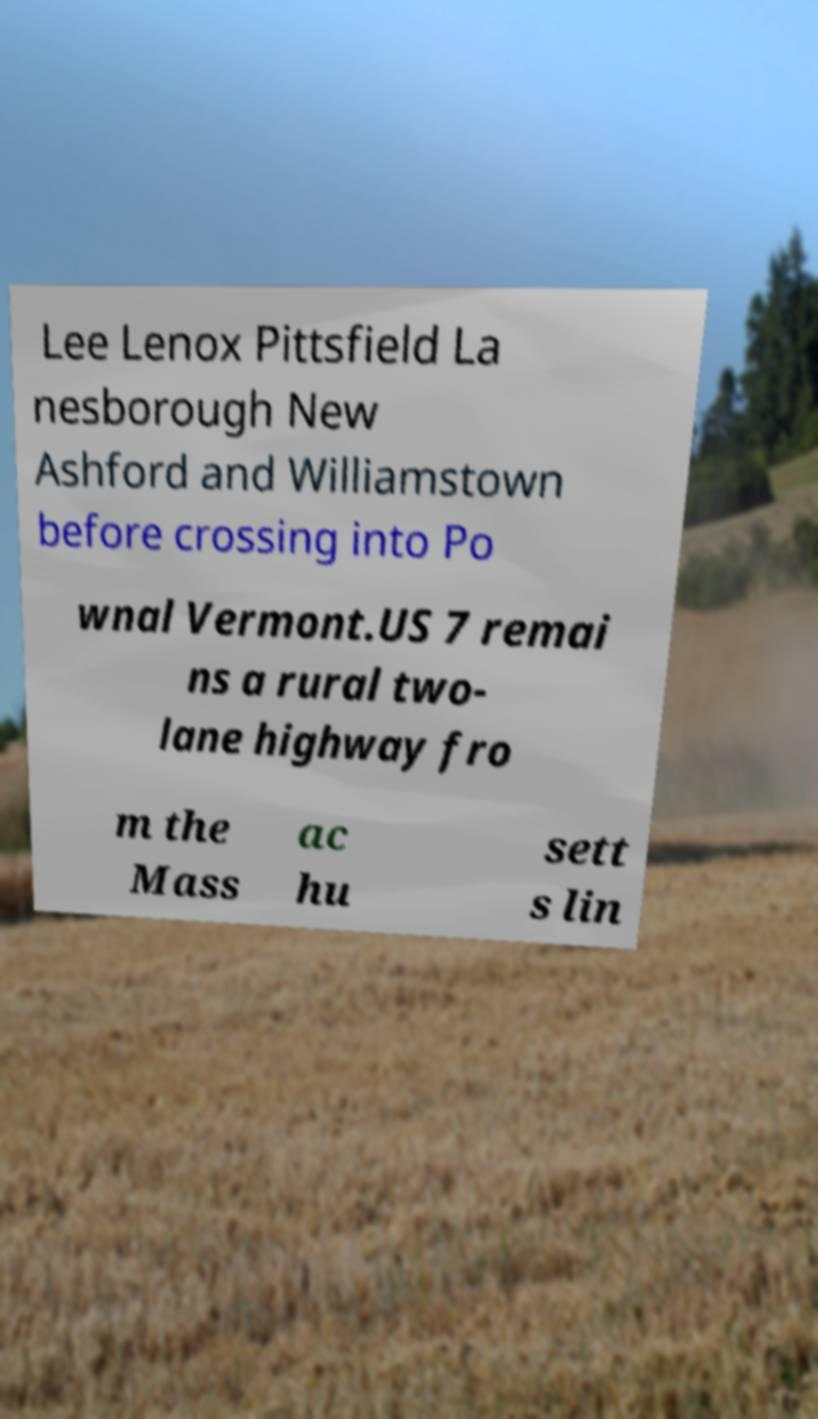Can you read and provide the text displayed in the image?This photo seems to have some interesting text. Can you extract and type it out for me? Lee Lenox Pittsfield La nesborough New Ashford and Williamstown before crossing into Po wnal Vermont.US 7 remai ns a rural two- lane highway fro m the Mass ac hu sett s lin 